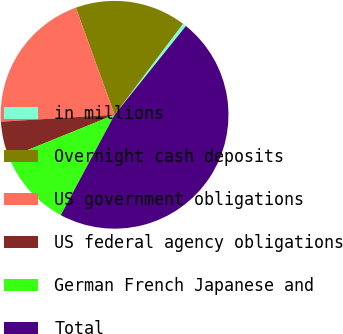<chart> <loc_0><loc_0><loc_500><loc_500><pie_chart><fcel>in millions<fcel>Overnight cash deposits<fcel>US government obligations<fcel>US federal agency obligations<fcel>German French Japanese and<fcel>Total<nl><fcel>0.52%<fcel>15.78%<fcel>20.44%<fcel>5.17%<fcel>11.03%<fcel>47.06%<nl></chart> 